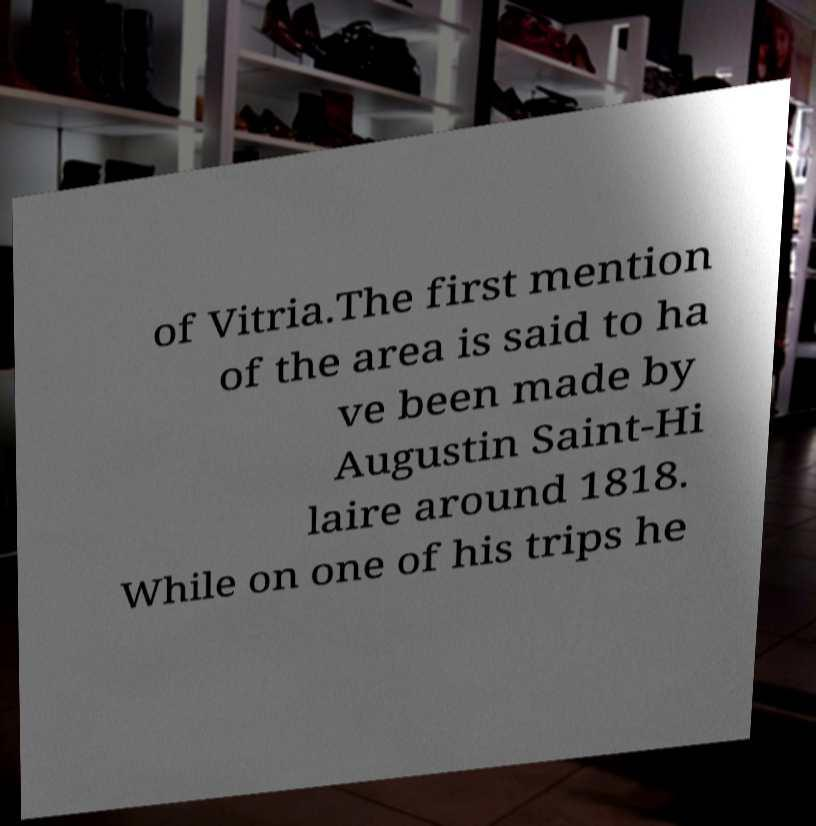Please read and relay the text visible in this image. What does it say? of Vitria.The first mention of the area is said to ha ve been made by Augustin Saint-Hi laire around 1818. While on one of his trips he 